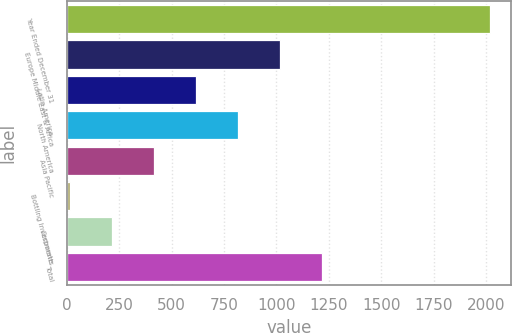Convert chart to OTSL. <chart><loc_0><loc_0><loc_500><loc_500><bar_chart><fcel>Year Ended December 31<fcel>Europe Middle East & Africa<fcel>Latin America<fcel>North America<fcel>Asia Pacific<fcel>Bottling Investments<fcel>Corporate<fcel>Total<nl><fcel>2017<fcel>1014.85<fcel>613.99<fcel>814.42<fcel>413.56<fcel>12.7<fcel>213.13<fcel>1215.28<nl></chart> 